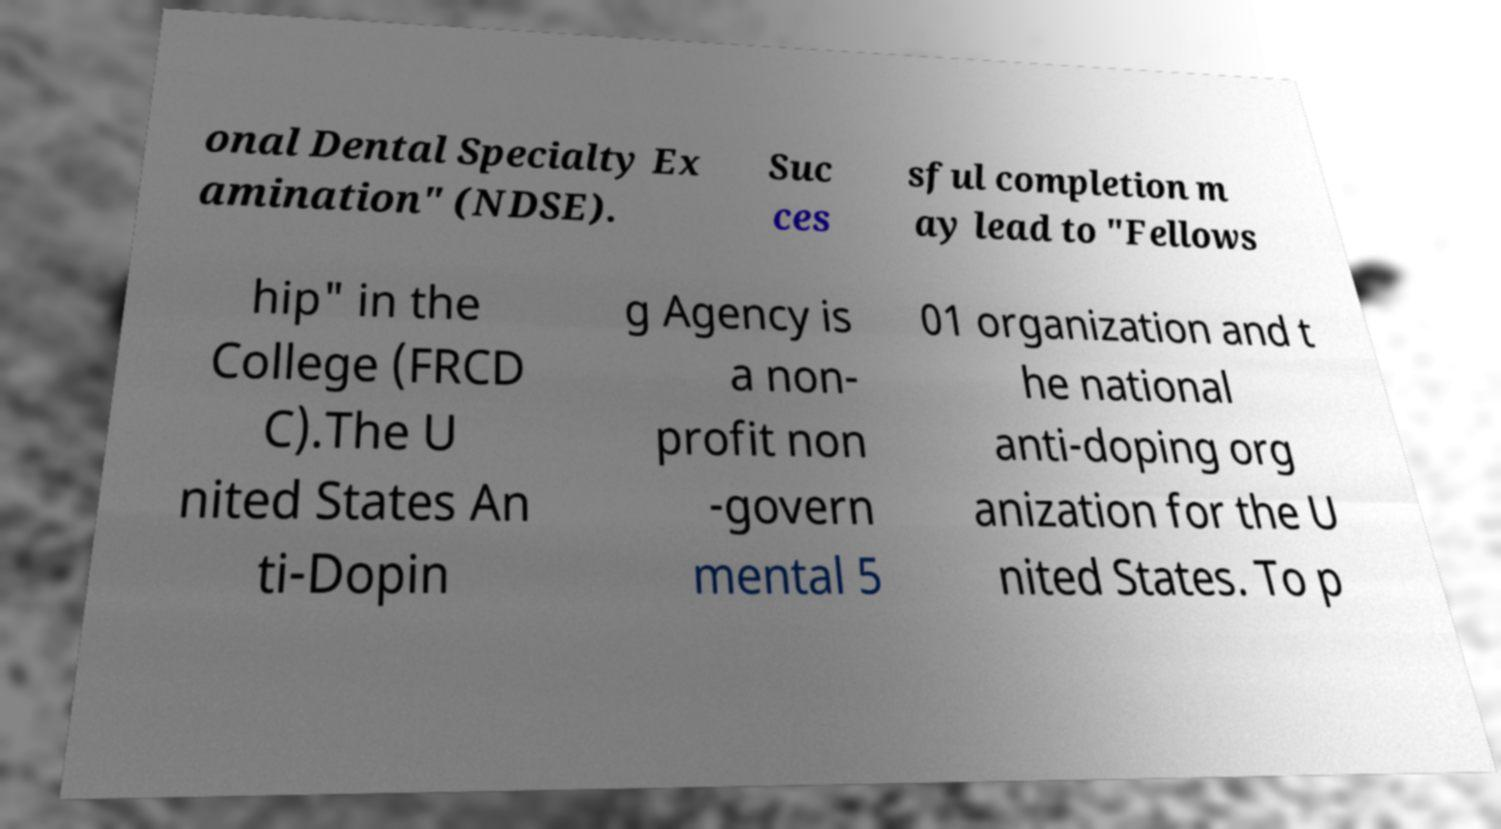For documentation purposes, I need the text within this image transcribed. Could you provide that? onal Dental Specialty Ex amination" (NDSE). Suc ces sful completion m ay lead to "Fellows hip" in the College (FRCD C).The U nited States An ti-Dopin g Agency is a non- profit non -govern mental 5 01 organization and t he national anti-doping org anization for the U nited States. To p 